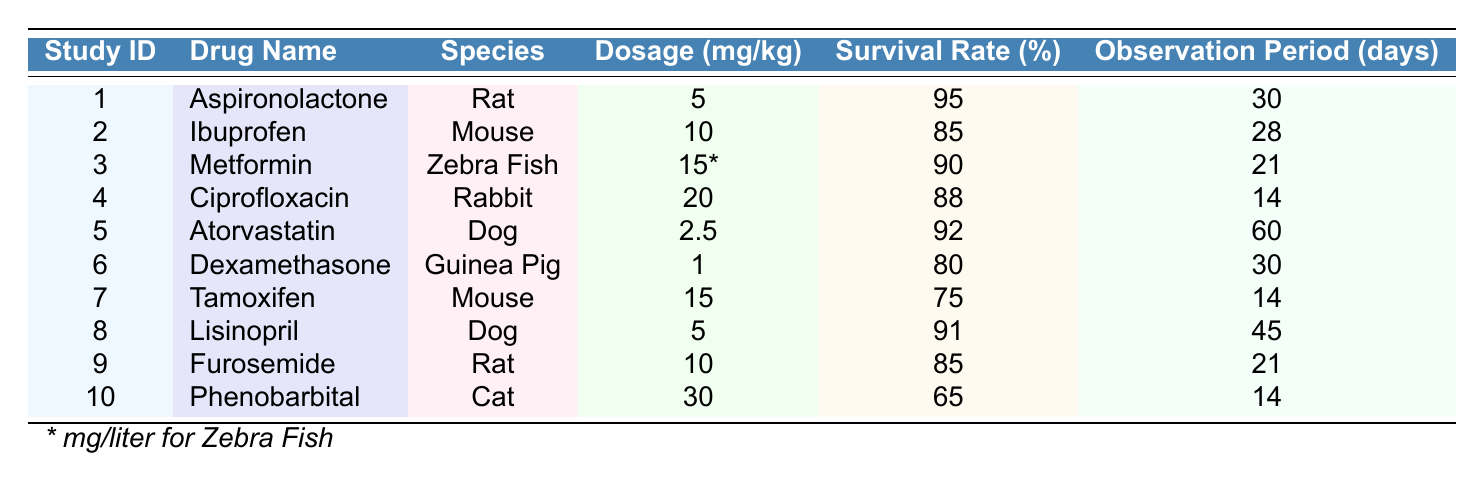What is the survival rate of Aspironolactone in rats? The table shows that the survival rate for Aspironolactone in rats is presented in the row for study ID 1, which states that it is 95 percent.
Answer: 95% Which drug had the lowest survival rate among those tested? By examining the survival rates from the table, the lowest value is for Phenobarbital in cats, which has a survival rate of 65 percent.
Answer: 65% What is the average survival rate of the drugs tested on dogs? The survival rates for dogs are 92 percent for Atorvastatin (study 5) and 91 percent for Lisinopril (study 8). Adding these gives 183, and dividing by 2 yields an average of 91.5 percent.
Answer: 91.5% Which species had the highest survival rate and what was that rate? Among the species listed, rats on Aspironolactone had the highest survival rate of 95 percent.
Answer: Rats, 95% Is the observation period for Dexamethasone longer than for Tamoxifen? The observation period for Dexamethasone is 30 days, while for Tamoxifen, it is 14 days. Since 30 is greater than 14, the statement is true.
Answer: Yes What is the difference in survival rates between therapeutic doses of Ibuprofen and Ciprofloxacin? The survival rate for Ibuprofen is 85 percent and for Ciprofloxacin, it is 88 percent. The difference is 88 - 85 = 3 percent.
Answer: 3% How many studies involved mice, and what were their survival rates? The table indicates that there are two studies involving mice (Ibuprofen and Tamoxifen) with survival rates of 85 percent and 75 percent respectively.
Answer: 2, 85%, 75% What drug provided the highest dosage per kilogram, and what was the survival rate for that drug? Looking through the dosages in the table, Ciprofloxacin had the highest dosage of 20 mg/kg, with a survival rate of 88 percent.
Answer: Ciprofloxacin, 88% If the average dosage for zebra fish is considered, how does it compare to the one used for rats? The dosage for zebra fish is 15 mg/liter, while for rats, the dosages are 5 mg/kg for Aspironolactone and 10 mg/kg for Furosemide. Comparing them requires conversion, and they are not directly comparable without knowing the volume of water considered for zebrafish, thus no direct numerical comparison can be made.
Answer: Not directly comparable What is the combined survival rate percentage of the drugs tested on guinea pigs and cats? The survival rate for guinea pigs taking Dexamethasone is 80 percent and for cats on Phenobarbital is 65 percent. Adding these gives 80 + 65 = 145 percent.
Answer: 145% 